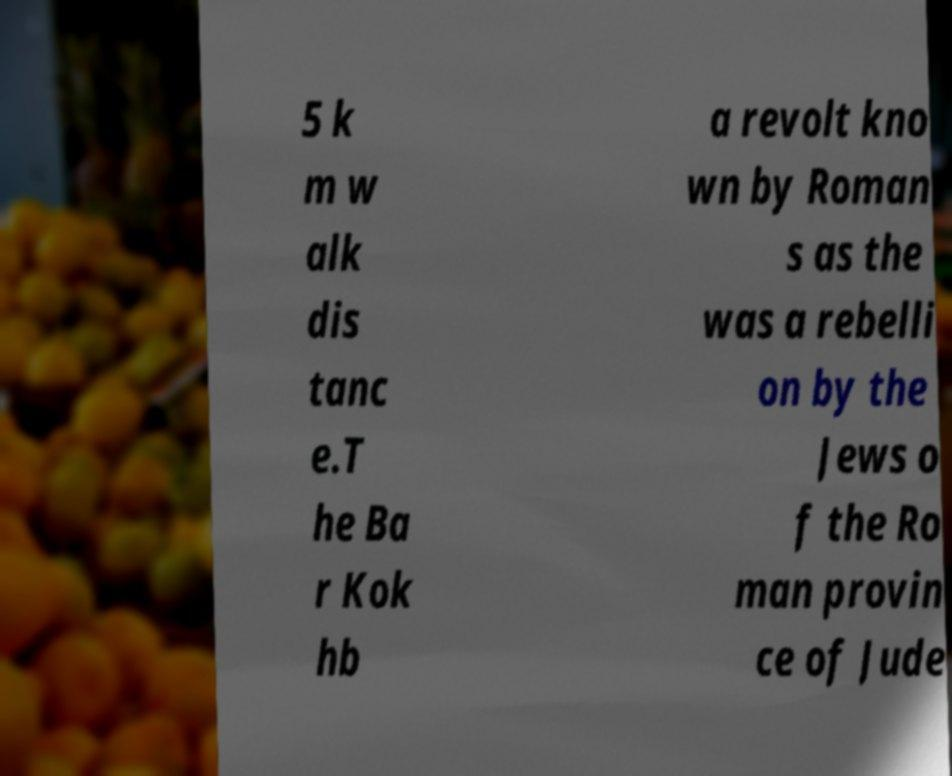What messages or text are displayed in this image? I need them in a readable, typed format. 5 k m w alk dis tanc e.T he Ba r Kok hb a revolt kno wn by Roman s as the was a rebelli on by the Jews o f the Ro man provin ce of Jude 